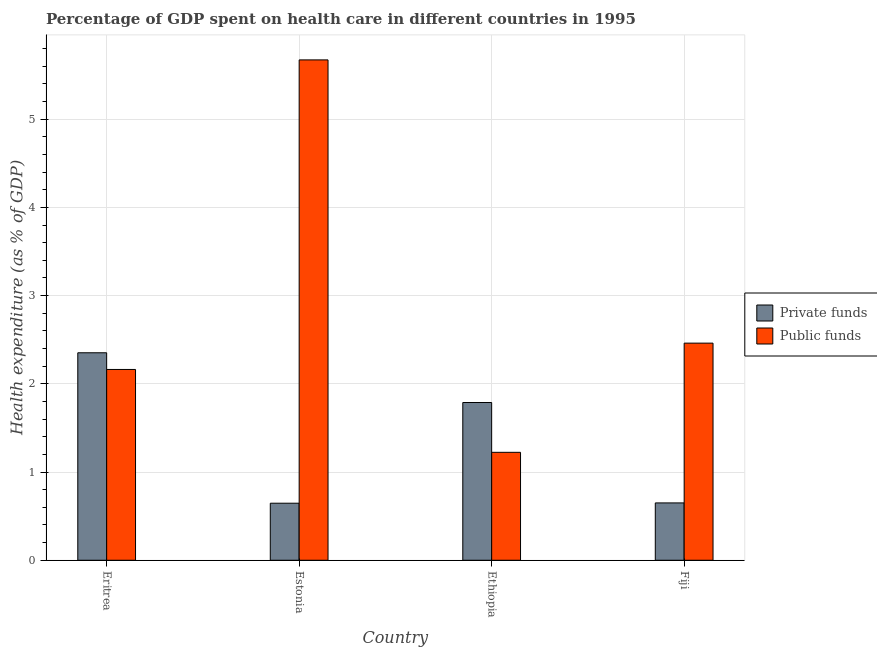How many different coloured bars are there?
Provide a succinct answer. 2. How many bars are there on the 4th tick from the right?
Your answer should be very brief. 2. What is the label of the 3rd group of bars from the left?
Provide a short and direct response. Ethiopia. What is the amount of public funds spent in healthcare in Ethiopia?
Offer a very short reply. 1.22. Across all countries, what is the maximum amount of private funds spent in healthcare?
Give a very brief answer. 2.35. Across all countries, what is the minimum amount of private funds spent in healthcare?
Give a very brief answer. 0.65. In which country was the amount of private funds spent in healthcare maximum?
Offer a terse response. Eritrea. In which country was the amount of private funds spent in healthcare minimum?
Offer a very short reply. Estonia. What is the total amount of public funds spent in healthcare in the graph?
Offer a very short reply. 11.52. What is the difference between the amount of private funds spent in healthcare in Estonia and that in Fiji?
Your answer should be very brief. -0. What is the difference between the amount of private funds spent in healthcare in Estonia and the amount of public funds spent in healthcare in Ethiopia?
Your response must be concise. -0.58. What is the average amount of public funds spent in healthcare per country?
Your answer should be very brief. 2.88. What is the difference between the amount of private funds spent in healthcare and amount of public funds spent in healthcare in Ethiopia?
Provide a succinct answer. 0.56. What is the ratio of the amount of public funds spent in healthcare in Ethiopia to that in Fiji?
Offer a very short reply. 0.5. What is the difference between the highest and the second highest amount of private funds spent in healthcare?
Provide a succinct answer. 0.56. What is the difference between the highest and the lowest amount of public funds spent in healthcare?
Give a very brief answer. 4.45. Is the sum of the amount of private funds spent in healthcare in Eritrea and Ethiopia greater than the maximum amount of public funds spent in healthcare across all countries?
Give a very brief answer. No. What does the 2nd bar from the left in Estonia represents?
Offer a terse response. Public funds. What does the 1st bar from the right in Fiji represents?
Your answer should be very brief. Public funds. Are all the bars in the graph horizontal?
Your answer should be compact. No. Are the values on the major ticks of Y-axis written in scientific E-notation?
Your response must be concise. No. Does the graph contain any zero values?
Keep it short and to the point. No. Does the graph contain grids?
Your answer should be compact. Yes. How many legend labels are there?
Give a very brief answer. 2. How are the legend labels stacked?
Keep it short and to the point. Vertical. What is the title of the graph?
Your answer should be compact. Percentage of GDP spent on health care in different countries in 1995. Does "Excluding technical cooperation" appear as one of the legend labels in the graph?
Your answer should be very brief. No. What is the label or title of the Y-axis?
Provide a succinct answer. Health expenditure (as % of GDP). What is the Health expenditure (as % of GDP) of Private funds in Eritrea?
Your response must be concise. 2.35. What is the Health expenditure (as % of GDP) of Public funds in Eritrea?
Offer a terse response. 2.16. What is the Health expenditure (as % of GDP) in Private funds in Estonia?
Your response must be concise. 0.65. What is the Health expenditure (as % of GDP) in Public funds in Estonia?
Give a very brief answer. 5.67. What is the Health expenditure (as % of GDP) of Private funds in Ethiopia?
Provide a succinct answer. 1.79. What is the Health expenditure (as % of GDP) in Public funds in Ethiopia?
Make the answer very short. 1.22. What is the Health expenditure (as % of GDP) in Private funds in Fiji?
Offer a very short reply. 0.65. What is the Health expenditure (as % of GDP) of Public funds in Fiji?
Provide a short and direct response. 2.46. Across all countries, what is the maximum Health expenditure (as % of GDP) in Private funds?
Keep it short and to the point. 2.35. Across all countries, what is the maximum Health expenditure (as % of GDP) in Public funds?
Make the answer very short. 5.67. Across all countries, what is the minimum Health expenditure (as % of GDP) in Private funds?
Keep it short and to the point. 0.65. Across all countries, what is the minimum Health expenditure (as % of GDP) in Public funds?
Offer a very short reply. 1.22. What is the total Health expenditure (as % of GDP) of Private funds in the graph?
Provide a short and direct response. 5.44. What is the total Health expenditure (as % of GDP) in Public funds in the graph?
Your answer should be very brief. 11.52. What is the difference between the Health expenditure (as % of GDP) of Private funds in Eritrea and that in Estonia?
Offer a terse response. 1.71. What is the difference between the Health expenditure (as % of GDP) in Public funds in Eritrea and that in Estonia?
Keep it short and to the point. -3.51. What is the difference between the Health expenditure (as % of GDP) in Private funds in Eritrea and that in Ethiopia?
Your response must be concise. 0.56. What is the difference between the Health expenditure (as % of GDP) of Public funds in Eritrea and that in Ethiopia?
Provide a short and direct response. 0.94. What is the difference between the Health expenditure (as % of GDP) of Private funds in Eritrea and that in Fiji?
Make the answer very short. 1.7. What is the difference between the Health expenditure (as % of GDP) of Public funds in Eritrea and that in Fiji?
Your response must be concise. -0.3. What is the difference between the Health expenditure (as % of GDP) of Private funds in Estonia and that in Ethiopia?
Your response must be concise. -1.14. What is the difference between the Health expenditure (as % of GDP) in Public funds in Estonia and that in Ethiopia?
Provide a succinct answer. 4.45. What is the difference between the Health expenditure (as % of GDP) of Private funds in Estonia and that in Fiji?
Provide a succinct answer. -0. What is the difference between the Health expenditure (as % of GDP) in Public funds in Estonia and that in Fiji?
Your answer should be compact. 3.21. What is the difference between the Health expenditure (as % of GDP) of Private funds in Ethiopia and that in Fiji?
Make the answer very short. 1.14. What is the difference between the Health expenditure (as % of GDP) of Public funds in Ethiopia and that in Fiji?
Your response must be concise. -1.24. What is the difference between the Health expenditure (as % of GDP) in Private funds in Eritrea and the Health expenditure (as % of GDP) in Public funds in Estonia?
Keep it short and to the point. -3.32. What is the difference between the Health expenditure (as % of GDP) of Private funds in Eritrea and the Health expenditure (as % of GDP) of Public funds in Ethiopia?
Ensure brevity in your answer.  1.13. What is the difference between the Health expenditure (as % of GDP) of Private funds in Eritrea and the Health expenditure (as % of GDP) of Public funds in Fiji?
Ensure brevity in your answer.  -0.11. What is the difference between the Health expenditure (as % of GDP) in Private funds in Estonia and the Health expenditure (as % of GDP) in Public funds in Ethiopia?
Your response must be concise. -0.58. What is the difference between the Health expenditure (as % of GDP) in Private funds in Estonia and the Health expenditure (as % of GDP) in Public funds in Fiji?
Make the answer very short. -1.81. What is the difference between the Health expenditure (as % of GDP) of Private funds in Ethiopia and the Health expenditure (as % of GDP) of Public funds in Fiji?
Provide a short and direct response. -0.67. What is the average Health expenditure (as % of GDP) in Private funds per country?
Provide a short and direct response. 1.36. What is the average Health expenditure (as % of GDP) of Public funds per country?
Your response must be concise. 2.88. What is the difference between the Health expenditure (as % of GDP) of Private funds and Health expenditure (as % of GDP) of Public funds in Eritrea?
Provide a succinct answer. 0.19. What is the difference between the Health expenditure (as % of GDP) in Private funds and Health expenditure (as % of GDP) in Public funds in Estonia?
Provide a short and direct response. -5.02. What is the difference between the Health expenditure (as % of GDP) in Private funds and Health expenditure (as % of GDP) in Public funds in Ethiopia?
Your answer should be compact. 0.56. What is the difference between the Health expenditure (as % of GDP) in Private funds and Health expenditure (as % of GDP) in Public funds in Fiji?
Ensure brevity in your answer.  -1.81. What is the ratio of the Health expenditure (as % of GDP) of Private funds in Eritrea to that in Estonia?
Your response must be concise. 3.64. What is the ratio of the Health expenditure (as % of GDP) of Public funds in Eritrea to that in Estonia?
Give a very brief answer. 0.38. What is the ratio of the Health expenditure (as % of GDP) of Private funds in Eritrea to that in Ethiopia?
Your answer should be compact. 1.32. What is the ratio of the Health expenditure (as % of GDP) of Public funds in Eritrea to that in Ethiopia?
Offer a very short reply. 1.77. What is the ratio of the Health expenditure (as % of GDP) in Private funds in Eritrea to that in Fiji?
Offer a terse response. 3.62. What is the ratio of the Health expenditure (as % of GDP) of Public funds in Eritrea to that in Fiji?
Keep it short and to the point. 0.88. What is the ratio of the Health expenditure (as % of GDP) in Private funds in Estonia to that in Ethiopia?
Keep it short and to the point. 0.36. What is the ratio of the Health expenditure (as % of GDP) of Public funds in Estonia to that in Ethiopia?
Give a very brief answer. 4.64. What is the ratio of the Health expenditure (as % of GDP) of Private funds in Estonia to that in Fiji?
Offer a very short reply. 0.99. What is the ratio of the Health expenditure (as % of GDP) of Public funds in Estonia to that in Fiji?
Your response must be concise. 2.3. What is the ratio of the Health expenditure (as % of GDP) in Private funds in Ethiopia to that in Fiji?
Your response must be concise. 2.75. What is the ratio of the Health expenditure (as % of GDP) of Public funds in Ethiopia to that in Fiji?
Make the answer very short. 0.5. What is the difference between the highest and the second highest Health expenditure (as % of GDP) in Private funds?
Ensure brevity in your answer.  0.56. What is the difference between the highest and the second highest Health expenditure (as % of GDP) in Public funds?
Provide a short and direct response. 3.21. What is the difference between the highest and the lowest Health expenditure (as % of GDP) of Private funds?
Your response must be concise. 1.71. What is the difference between the highest and the lowest Health expenditure (as % of GDP) of Public funds?
Give a very brief answer. 4.45. 